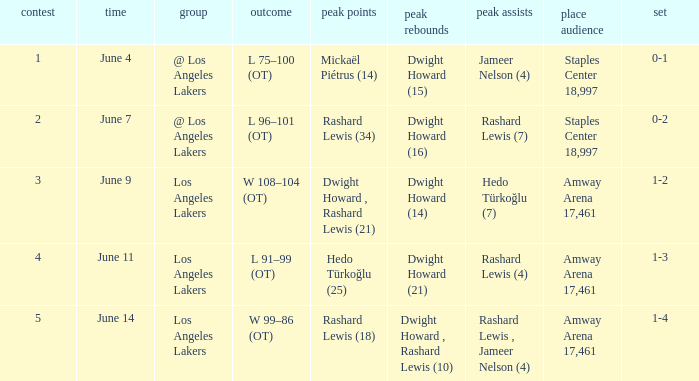What is the highest Game, when High Assists is "Hedo Türkoğlu (7)"? 3.0. 